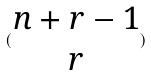<formula> <loc_0><loc_0><loc_500><loc_500>( \begin{matrix} n + r - 1 \\ r \end{matrix} )</formula> 